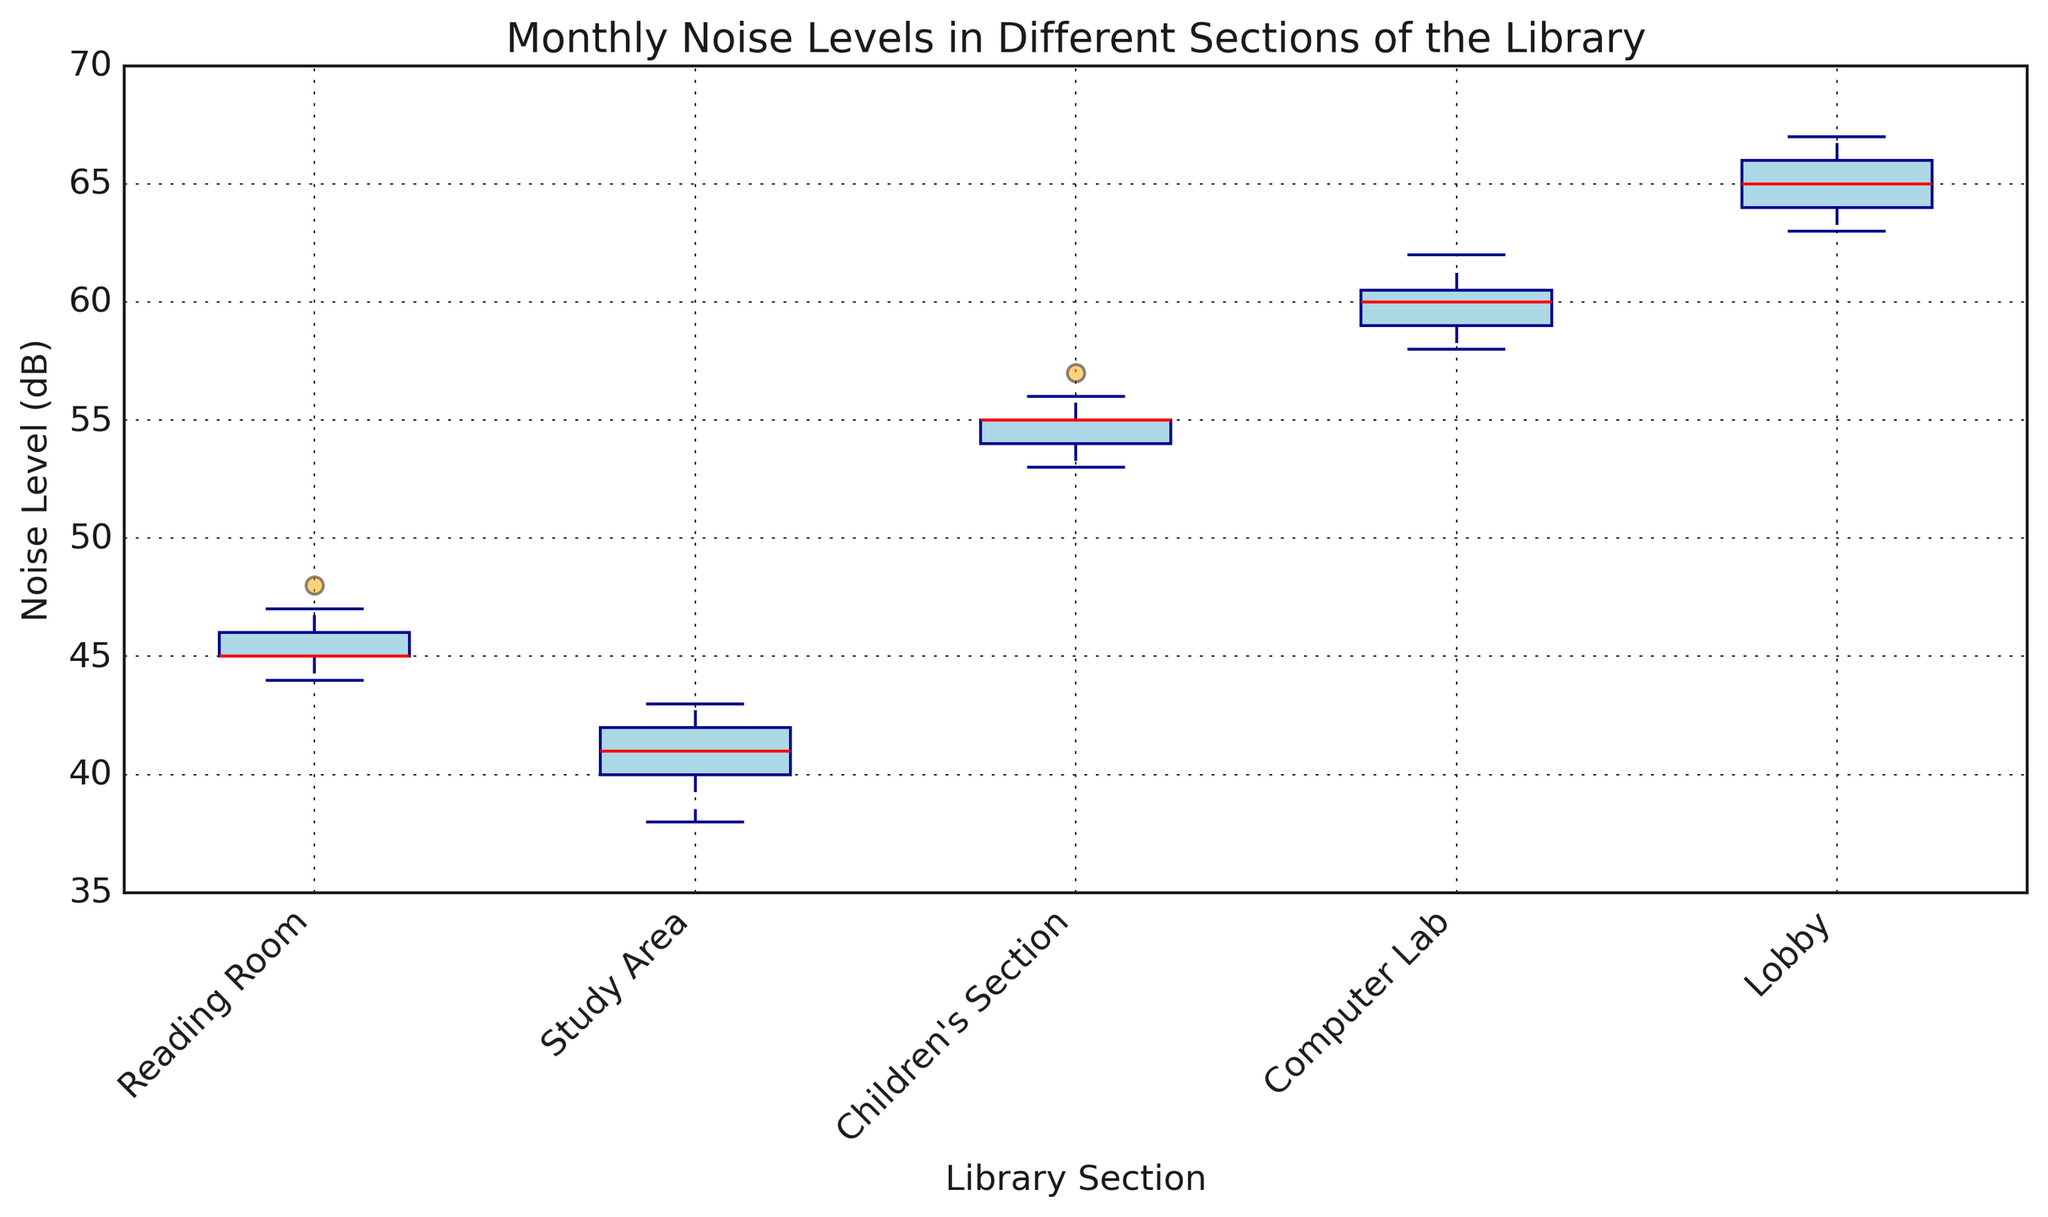Which section has the highest median noise level? To determine the section with the highest median noise level, identify the red line (median) within each box plot. The Computer Lab has the highest red line, indicating the highest median noise level.
Answer: Computer Lab Which section has the lowest average noise level in January? To find the section with the lowest average noise level in January, calculate the average noise levels for each section in January. The averages are: Reading Room (46.2), Study Area (39.2), Children’s Section (55.4), Computer Lab (60.4), and Lobby (64.8). The Study Area has the lowest average.
Answer: Study Area What is the range of noise levels in the Lobby section? To find the range, subtract the minimum value from the maximum value in the box plot for the Lobby section. The minimum value is the bottom whisker and the maximum value is the top whisker. For the Lobby, this range is from 63 to 67.
Answer: 4 dB Which section shows the most variation in noise levels? To find the section with the most variation, look for the widest spread between the whiskers in the box plot. The Computer Lab has the longest whiskers, indicating the most variation in noise levels.
Answer: Computer Lab Are there any outliers in the noise levels? To check for outliers, look for dots outside the whiskers in the box plots. The box plots do not show any dots outside the whiskers, indicating no outliers.
Answer: No How does the median noise level in the Reading Room in January compare to the median in the Children's Section in March? Compare the red lines (medians) of both sections. The median noise level in the Reading Room in January is lower than in the Children's Section in March.
Answer: Lower Which months have the highest and lowest median noise levels in the Study Area? Identify the red lines (medians) for each month in the Study Area. January has the lowest median, and March has the highest median.
Answer: January (lowest), March (highest) Is the average noise level higher in the Computer Lab or the Children’s Section in February? Calculate the average noise levels for both sections in February. The averages are: Computer Lab (59.2), Children’s Section (53.4). The Computer Lab has a higher average.
Answer: Computer Lab What is the interquartile range (IQR) of noise levels in the Reading Room? Calculate the IQR by subtracting the value at the 25th percentile (bottom of the box) from the value at the 75th percentile (top of the box) in the Reading Room box plot. This range appears to be approximately 2 dB.
Answer: 2 dB 